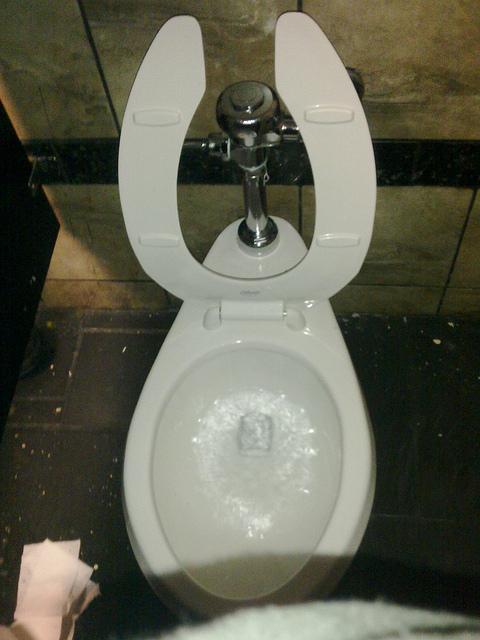What is the floor made of?
Concise answer only. Tile. How many lids are down?
Quick response, please. 0. Is the water in the bowl clean?
Keep it brief. Yes. Is there water in the seat?
Answer briefly. Yes. Which room is this?
Keep it brief. Bathroom. 